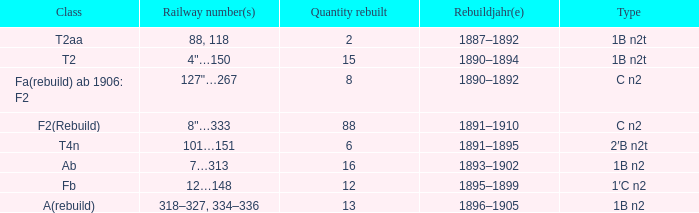What was the renewal year for the t2aa class? 1887–1892. 